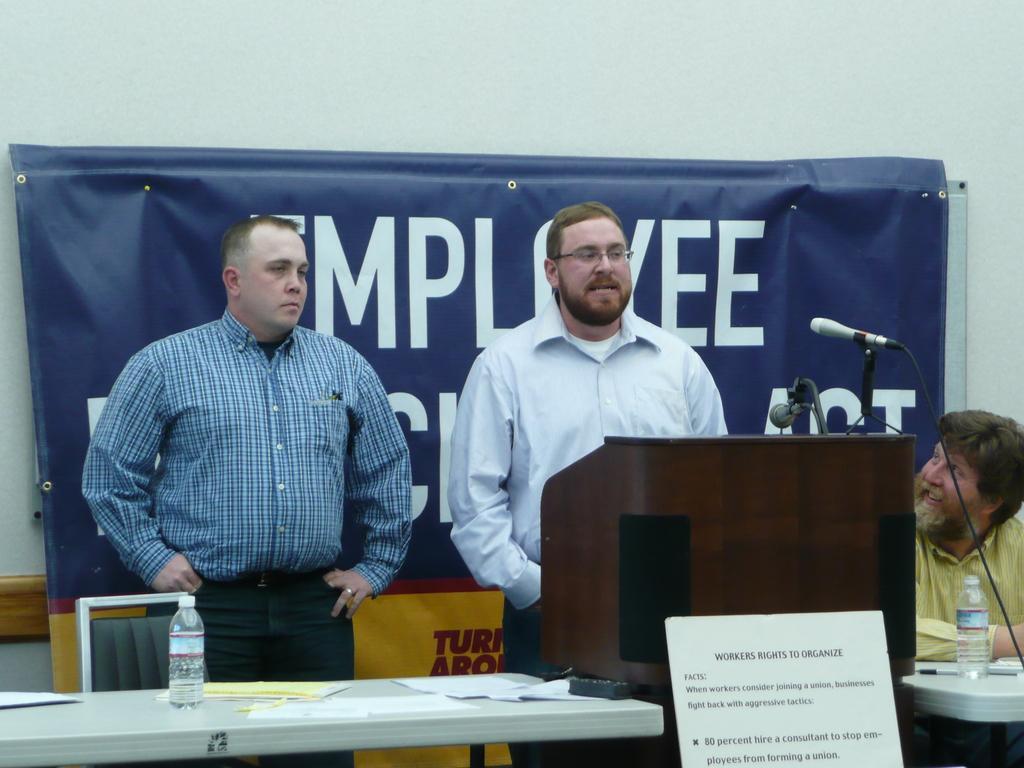Describe this image in one or two sentences. Persons are standing on the table we have bottle,paper another person sitting,here there is microphone,in the back there is poster. 